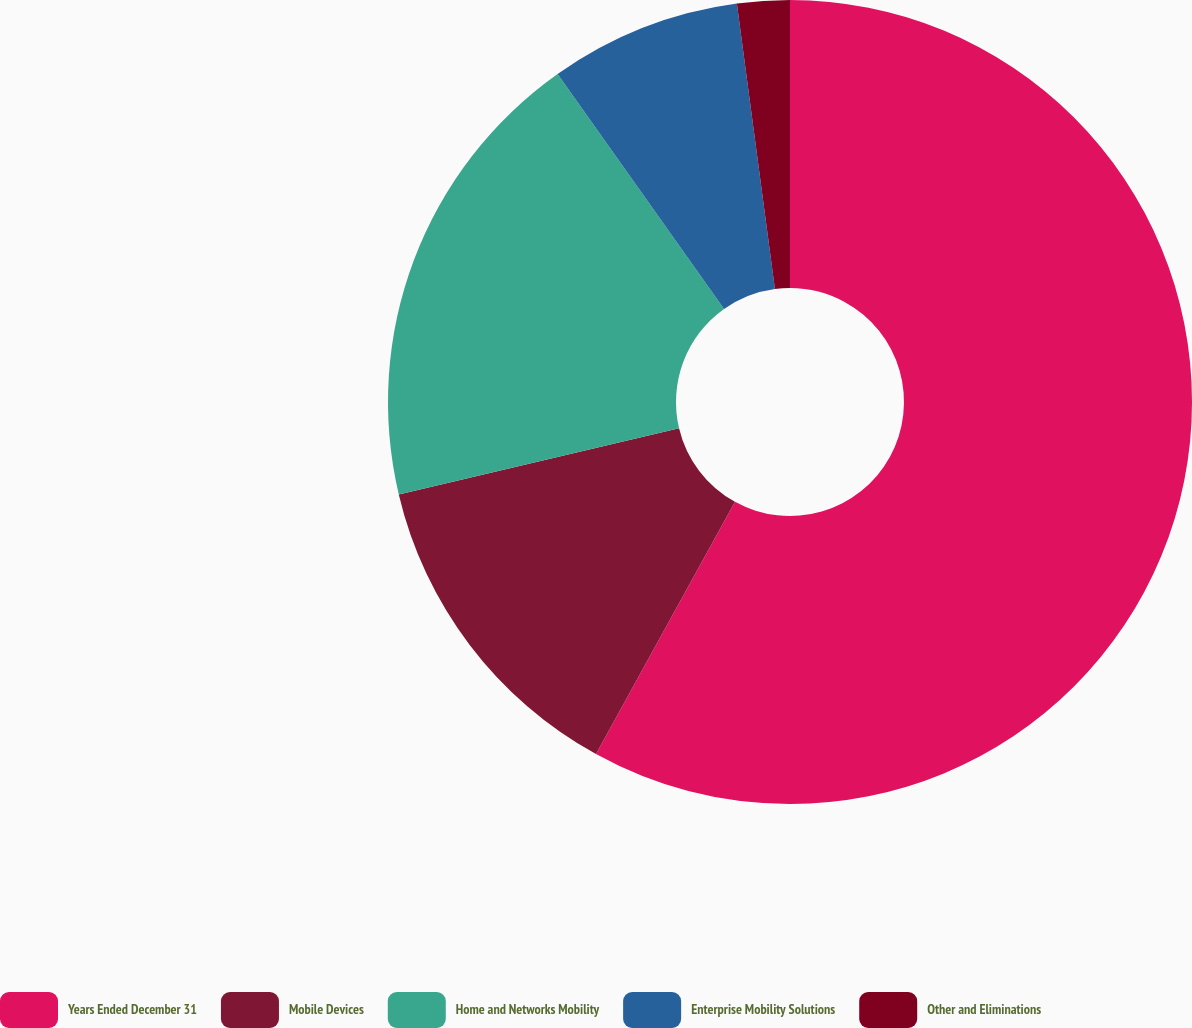<chart> <loc_0><loc_0><loc_500><loc_500><pie_chart><fcel>Years Ended December 31<fcel>Mobile Devices<fcel>Home and Networks Mobility<fcel>Enterprise Mobility Solutions<fcel>Other and Eliminations<nl><fcel>58.01%<fcel>13.29%<fcel>18.88%<fcel>7.7%<fcel>2.11%<nl></chart> 